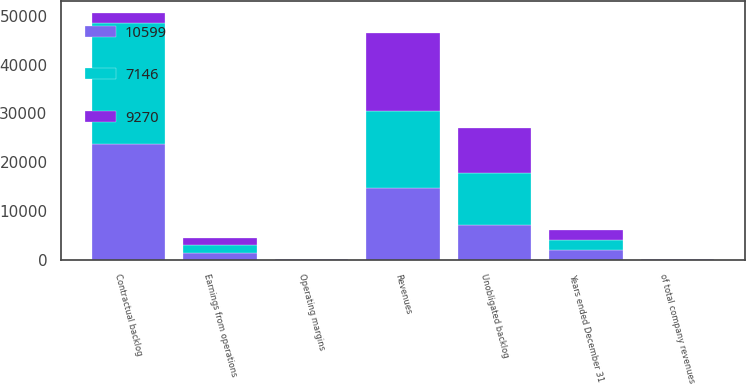Convert chart. <chart><loc_0><loc_0><loc_500><loc_500><stacked_bar_chart><ecel><fcel>Years ended December 31<fcel>Revenues<fcel>of total company revenues<fcel>Earnings from operations<fcel>Operating margins<fcel>Contractual backlog<fcel>Unobligated backlog<nl><fcel>7146<fcel>2013<fcel>15936<fcel>18<fcel>1465<fcel>9.2<fcel>24825<fcel>10599<nl><fcel>9270<fcel>2012<fcel>16019<fcel>20<fcel>1489<fcel>9.3<fcel>2011.5<fcel>9270<nl><fcel>10599<fcel>2011<fcel>14585<fcel>21<fcel>1431<fcel>9.8<fcel>23629<fcel>7146<nl></chart> 